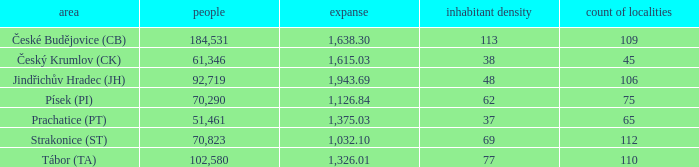What is the population density of the area with a population larger than 92,719? 2.0. 